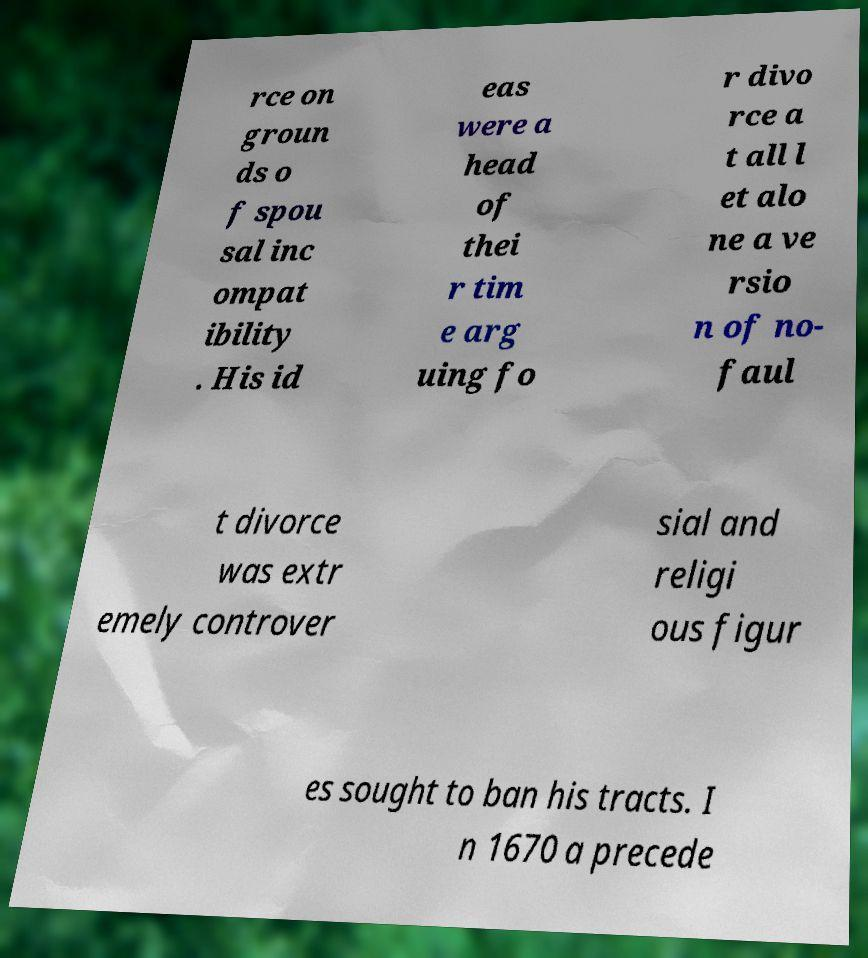Could you assist in decoding the text presented in this image and type it out clearly? rce on groun ds o f spou sal inc ompat ibility . His id eas were a head of thei r tim e arg uing fo r divo rce a t all l et alo ne a ve rsio n of no- faul t divorce was extr emely controver sial and religi ous figur es sought to ban his tracts. I n 1670 a precede 